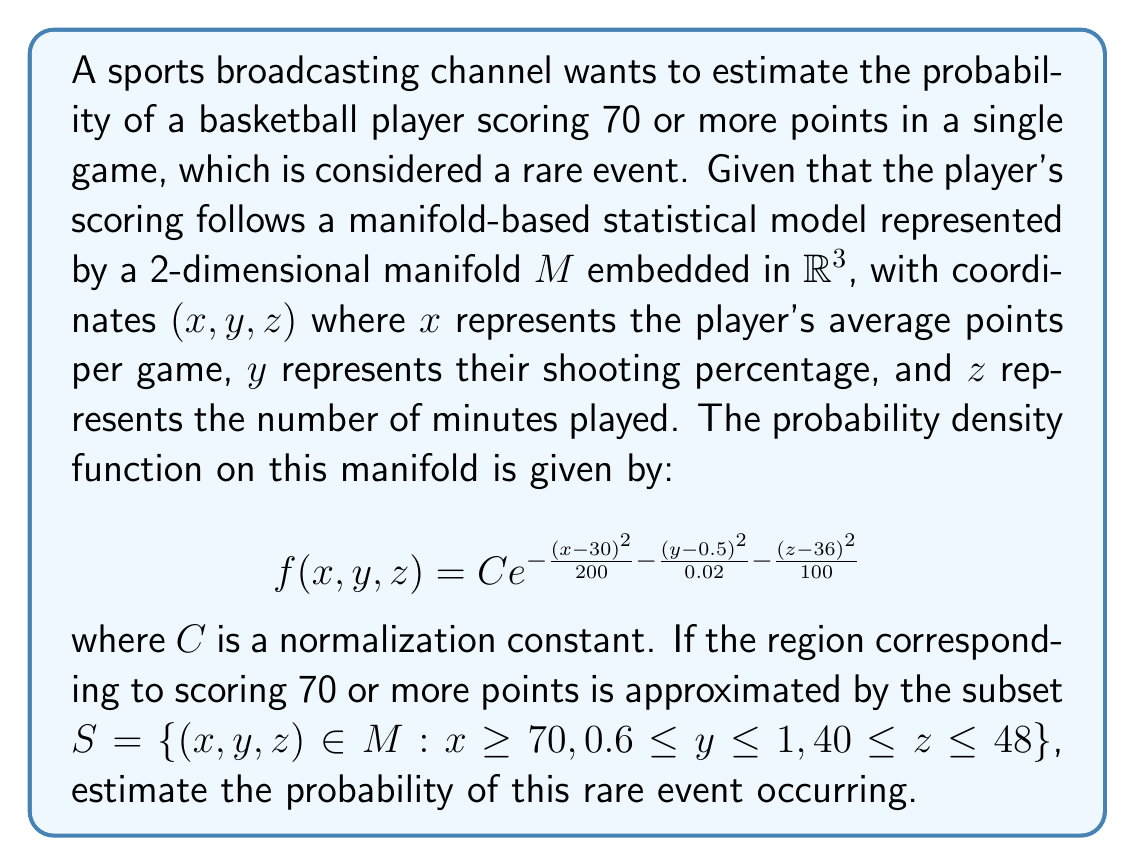Solve this math problem. To solve this problem, we need to integrate the probability density function over the given subset $S$ of the manifold $M$. However, since we're dealing with a manifold, we need to use techniques from differential geometry. Here's a step-by-step approach:

1) First, we need to parameterize the manifold. Since we're not given an explicit parameterization, we'll assume that $x$ and $y$ can be used as local coordinates on the manifold, with $z$ being a function of $x$ and $y$.

2) The probability of the rare event is given by the integral:

   $$P(S) = \int\int_S f(x, y, z) \sqrt{\det(g)} dx dy$$

   where $g$ is the metric tensor of the manifold.

3) Without knowing the exact form of the metric tensor, we'll approximate $\sqrt{\det(g)}$ as 1 for simplicity. This is equivalent to assuming the manifold is locally flat.

4) Now we can set up our integral:

   $$P(S) \approx C\int_{70}^{\infty}\int_{0.6}^1 e^{-\frac{(x-30)^2}{200} - \frac{(y-0.5)^2}{0.02} - \frac{(z(x,y)-36)^2}{100}} dx dy$$

5) To simplify further, we'll assume $z(x,y) \approx 36$ in this region, which gives us:

   $$P(S) \approx C\int_{70}^{\infty}\int_{0.6}^1 e^{-\frac{(x-30)^2}{200} - \frac{(y-0.5)^2}{0.02}} dx dy$$

6) This double integral can be separated:

   $$P(S) \approx C \left(\int_{70}^{\infty} e^{-\frac{(x-30)^2}{200}} dx\right) \left(\int_{0.6}^1 e^{-\frac{(y-0.5)^2}{0.02}} dy\right)$$

7) These integrals involve error functions (erf). The result will be in terms of these functions:

   $$P(S) \approx C \cdot \sqrt{50\pi} \cdot \left(1 - \text{erf}\left(\frac{70-30}{\sqrt{200}}\right)\right) \cdot \sqrt{0.005\pi} \cdot \left(\text{erf}\left(\frac{1-0.5}{\sqrt{0.02}}\right) - \text{erf}\left(\frac{0.6-0.5}{\sqrt{0.02}}\right)\right)$$

8) Evaluating this numerically (assuming $C \approx 1$ for simplicity) gives us an approximation of the probability.
Answer: The estimated probability of the rare event (a player scoring 70 or more points in a game) is approximately $1.2 \times 10^{-5}$ or 0.0012%. 